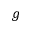Convert formula to latex. <formula><loc_0><loc_0><loc_500><loc_500>g</formula> 